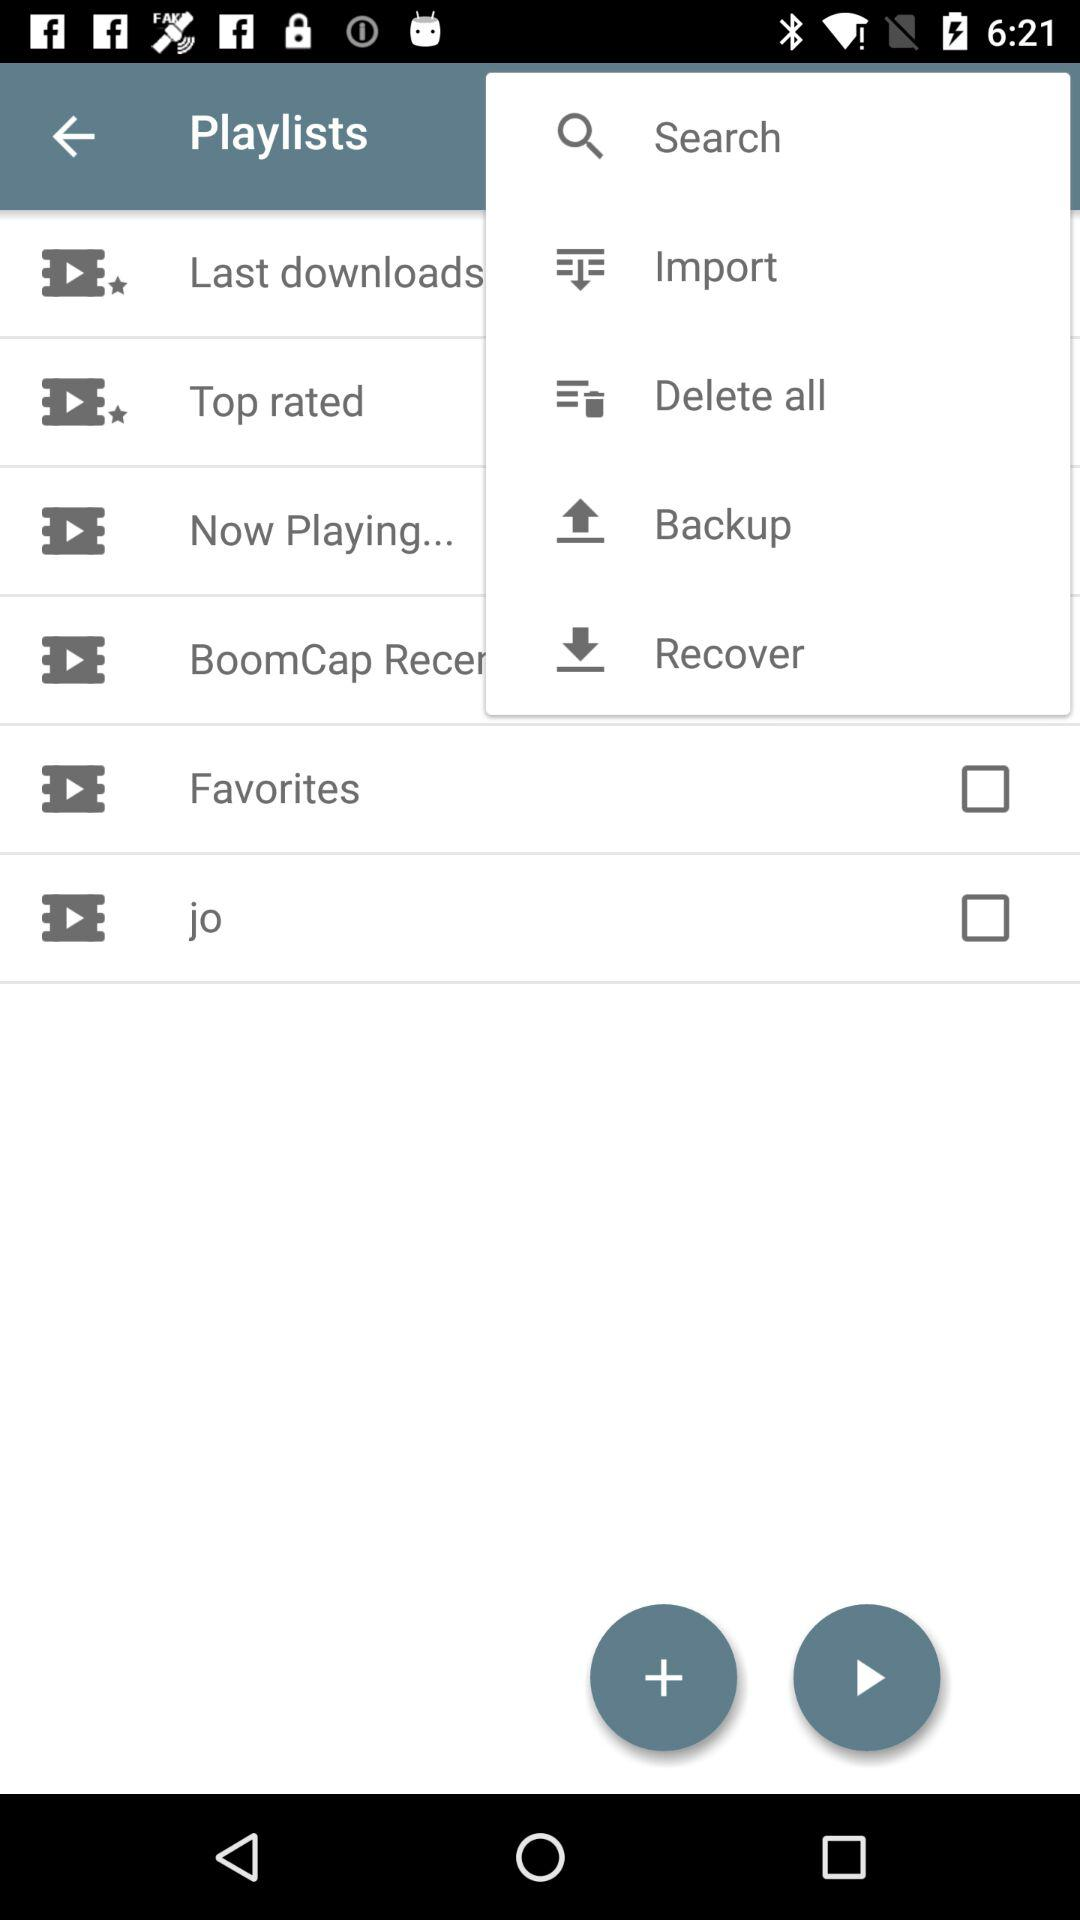What is the status of the "jo"? The status of the "jo" is "off". 